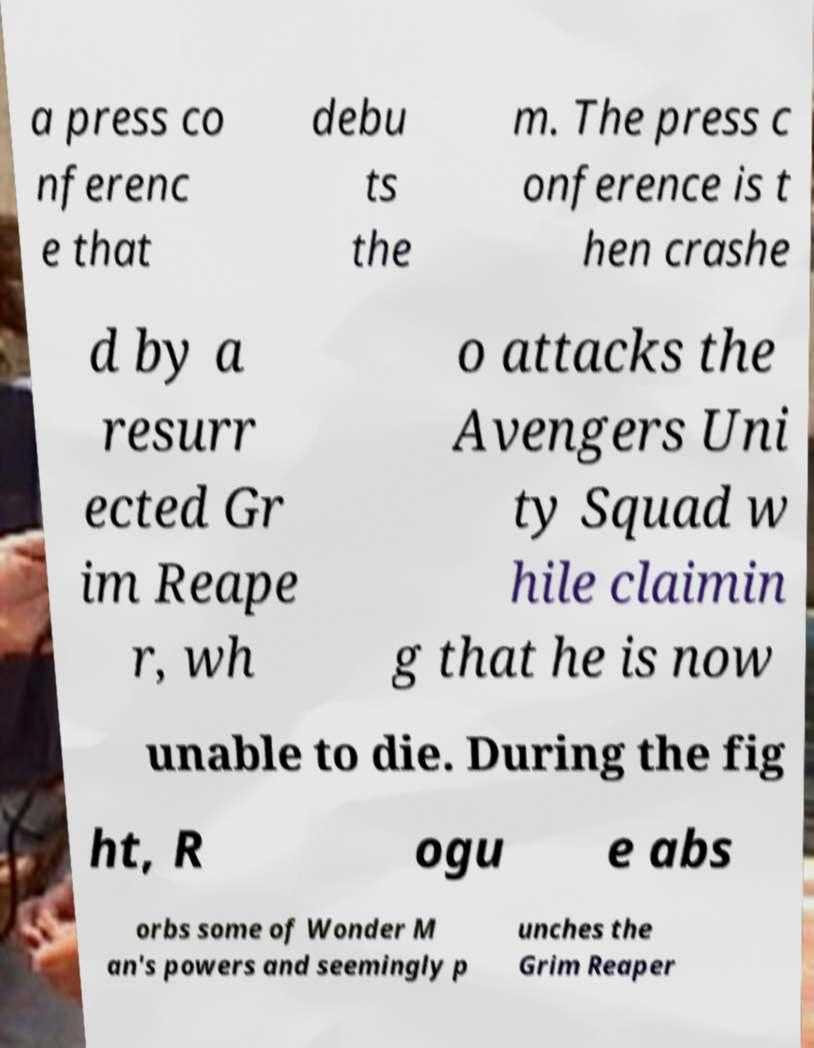Can you read and provide the text displayed in the image?This photo seems to have some interesting text. Can you extract and type it out for me? a press co nferenc e that debu ts the m. The press c onference is t hen crashe d by a resurr ected Gr im Reape r, wh o attacks the Avengers Uni ty Squad w hile claimin g that he is now unable to die. During the fig ht, R ogu e abs orbs some of Wonder M an's powers and seemingly p unches the Grim Reaper 